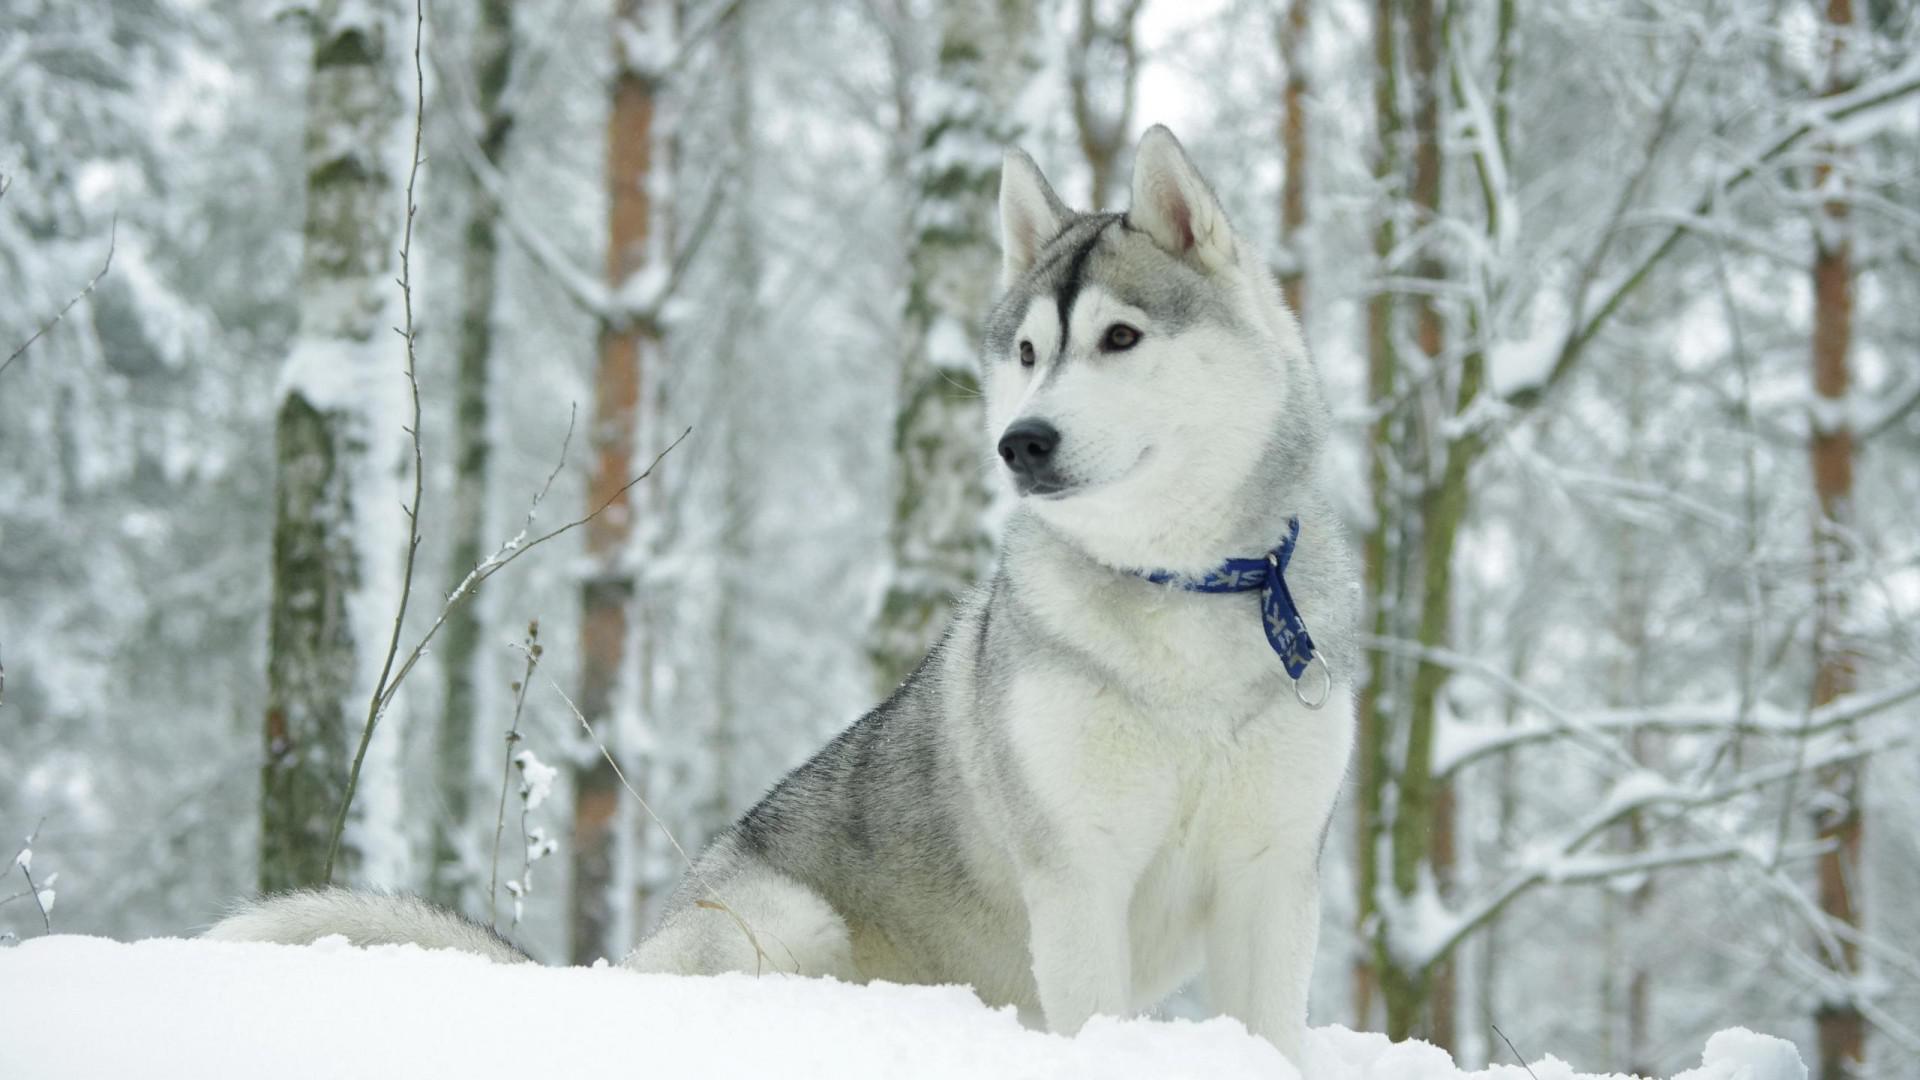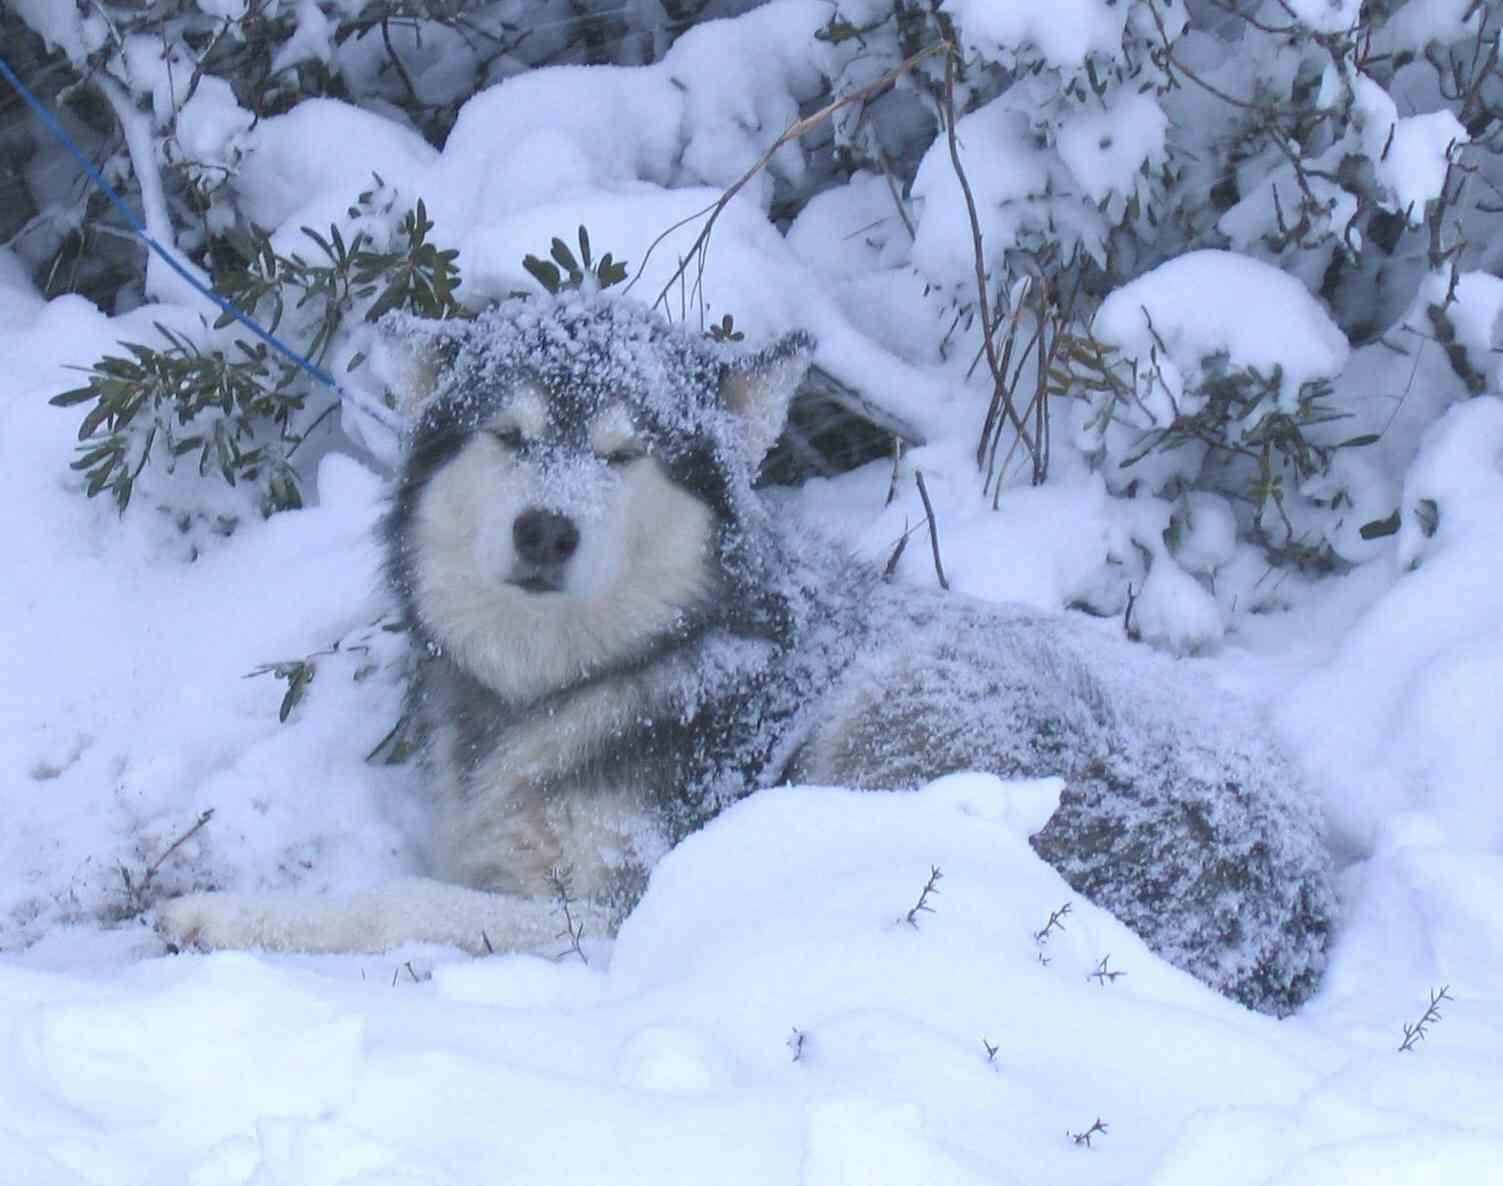The first image is the image on the left, the second image is the image on the right. Given the left and right images, does the statement "One image shows a dog sitting upright on snow-covered ground, and the other image shows a forward-facing dog with snow mounded in front of it." hold true? Answer yes or no. Yes. 